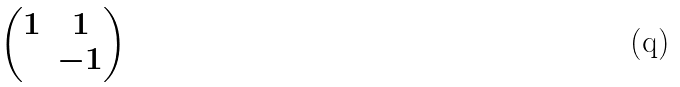Convert formula to latex. <formula><loc_0><loc_0><loc_500><loc_500>\begin{pmatrix} 1 & 1 \\ & - 1 \end{pmatrix}</formula> 